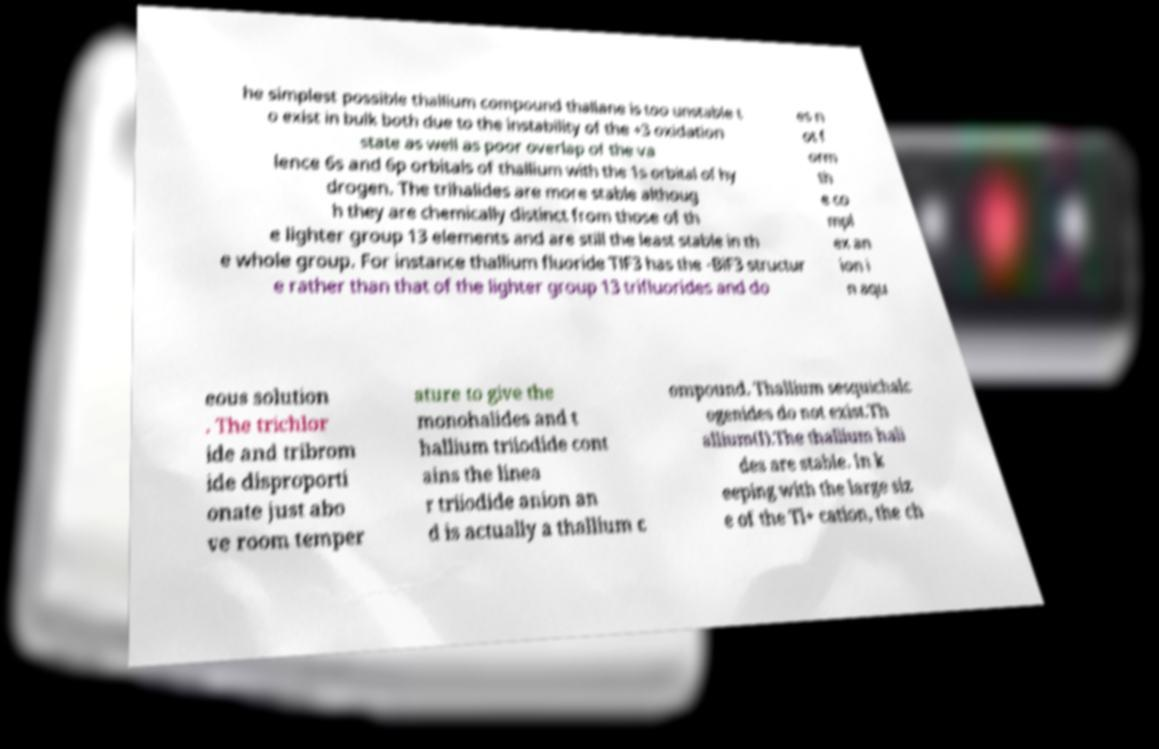For documentation purposes, I need the text within this image transcribed. Could you provide that? he simplest possible thallium compound thallane is too unstable t o exist in bulk both due to the instability of the +3 oxidation state as well as poor overlap of the va lence 6s and 6p orbitals of thallium with the 1s orbital of hy drogen. The trihalides are more stable althoug h they are chemically distinct from those of th e lighter group 13 elements and are still the least stable in th e whole group. For instance thallium fluoride TlF3 has the -BiF3 structur e rather than that of the lighter group 13 trifluorides and do es n ot f orm th e co mpl ex an ion i n aqu eous solution . The trichlor ide and tribrom ide disproporti onate just abo ve room temper ature to give the monohalides and t hallium triiodide cont ains the linea r triiodide anion an d is actually a thallium c ompound. Thallium sesquichalc ogenides do not exist.Th allium(I).The thallium hali des are stable. In k eeping with the large siz e of the Tl+ cation, the ch 